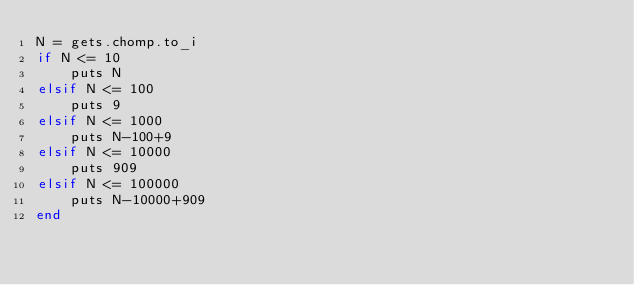<code> <loc_0><loc_0><loc_500><loc_500><_Ruby_>N = gets.chomp.to_i
if N <= 10
    puts N
elsif N <= 100
    puts 9
elsif N <= 1000
    puts N-100+9
elsif N <= 10000
    puts 909
elsif N <= 100000
    puts N-10000+909
end
</code> 